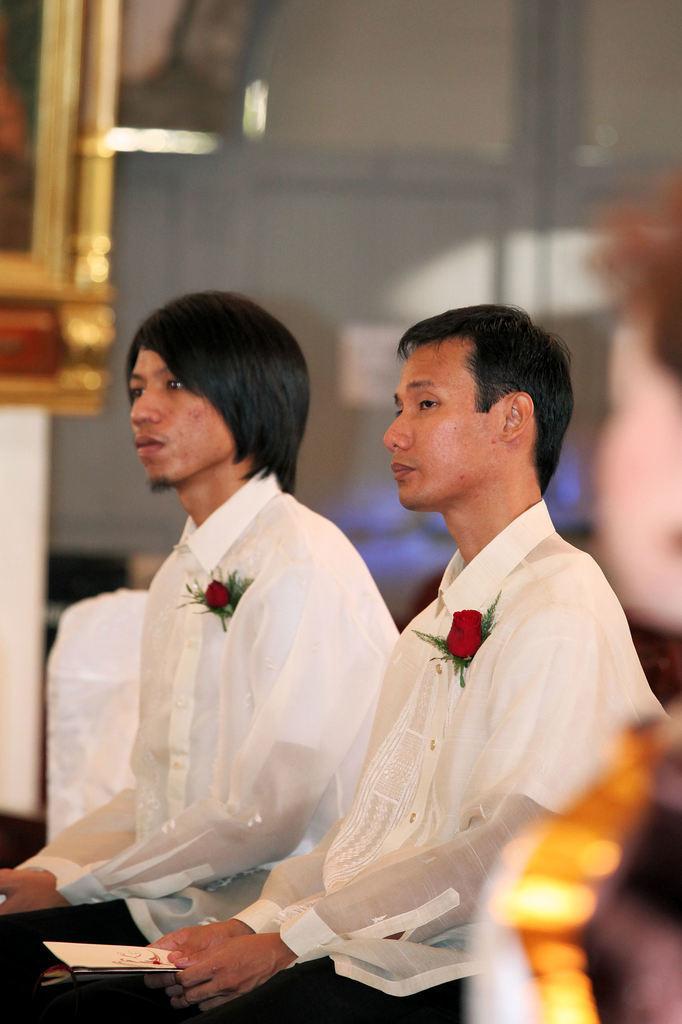In one or two sentences, can you explain what this image depicts? In this picture I can observe three members. Two of them are sitting in the middle of the picture. The background is blurred. 